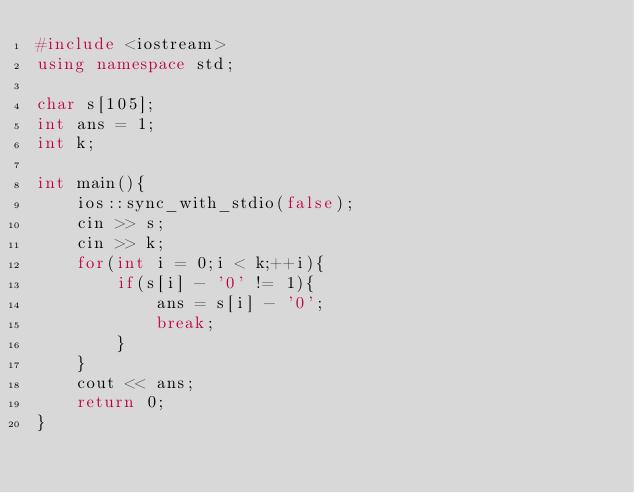<code> <loc_0><loc_0><loc_500><loc_500><_C++_>#include <iostream>
using namespace std;

char s[105];
int ans = 1;
int k;

int main(){
	ios::sync_with_stdio(false);
	cin >> s;
	cin >> k;
	for(int i = 0;i < k;++i){
		if(s[i] - '0' != 1){
			ans = s[i] - '0';
			break;
		}
	}
	cout << ans;
	return 0;
}</code> 